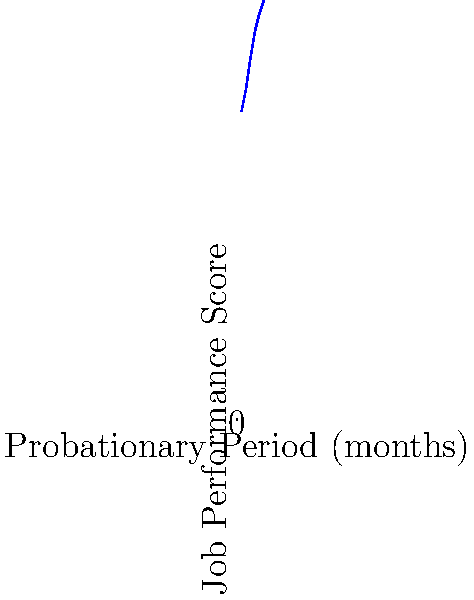Based on the scatter plot showing the relationship between probationary period length and job performance scores, what can be inferred about the effectiveness of longer probationary periods? How might this data influence HR policies on employee onboarding and evaluation? To answer this question, we need to analyze the scatter plot and interpret its implications:

1. Observe the trend: The scatter plot shows a clear positive correlation between probationary period length and job performance scores.

2. Interpret the correlation: As the probationary period increases from 1 to 6 months, the job performance scores consistently rise from 70 to 95.

3. Calculate the rate of improvement: The performance score increases by approximately 5 points per month of probation.

4. Consider the implications:
   a) Longer probationary periods seem to be associated with better job performance.
   b) This could be due to more time for training, adaptation, and skill development.
   c) Employees may also feel more motivated to perform well during extended probationary periods.

5. HR policy implications:
   a) Consider implementing longer probationary periods (up to 6 months) for new hires.
   b) Design comprehensive onboarding programs that utilize the full probationary period.
   c) Develop a structured evaluation process that aligns with the probationary period length.
   d) Balance the benefits of longer probations with potential drawbacks (e.g., employee stress, recruitment challenges).

6. Limitations to consider:
   a) Correlation does not imply causation; other factors may influence this relationship.
   b) The sample size and context of this data are not provided, which may affect its generalizability.
   c) The relationship may not be linear beyond 6 months, and diminishing returns could occur.

Based on this analysis, longer probationary periods appear to be effective in improving job performance, suggesting that HR policies should consider extended onboarding and evaluation periods to maximize employee potential.
Answer: Longer probationary periods correlate with improved job performance, suggesting HR should consider extended onboarding and evaluation programs. 